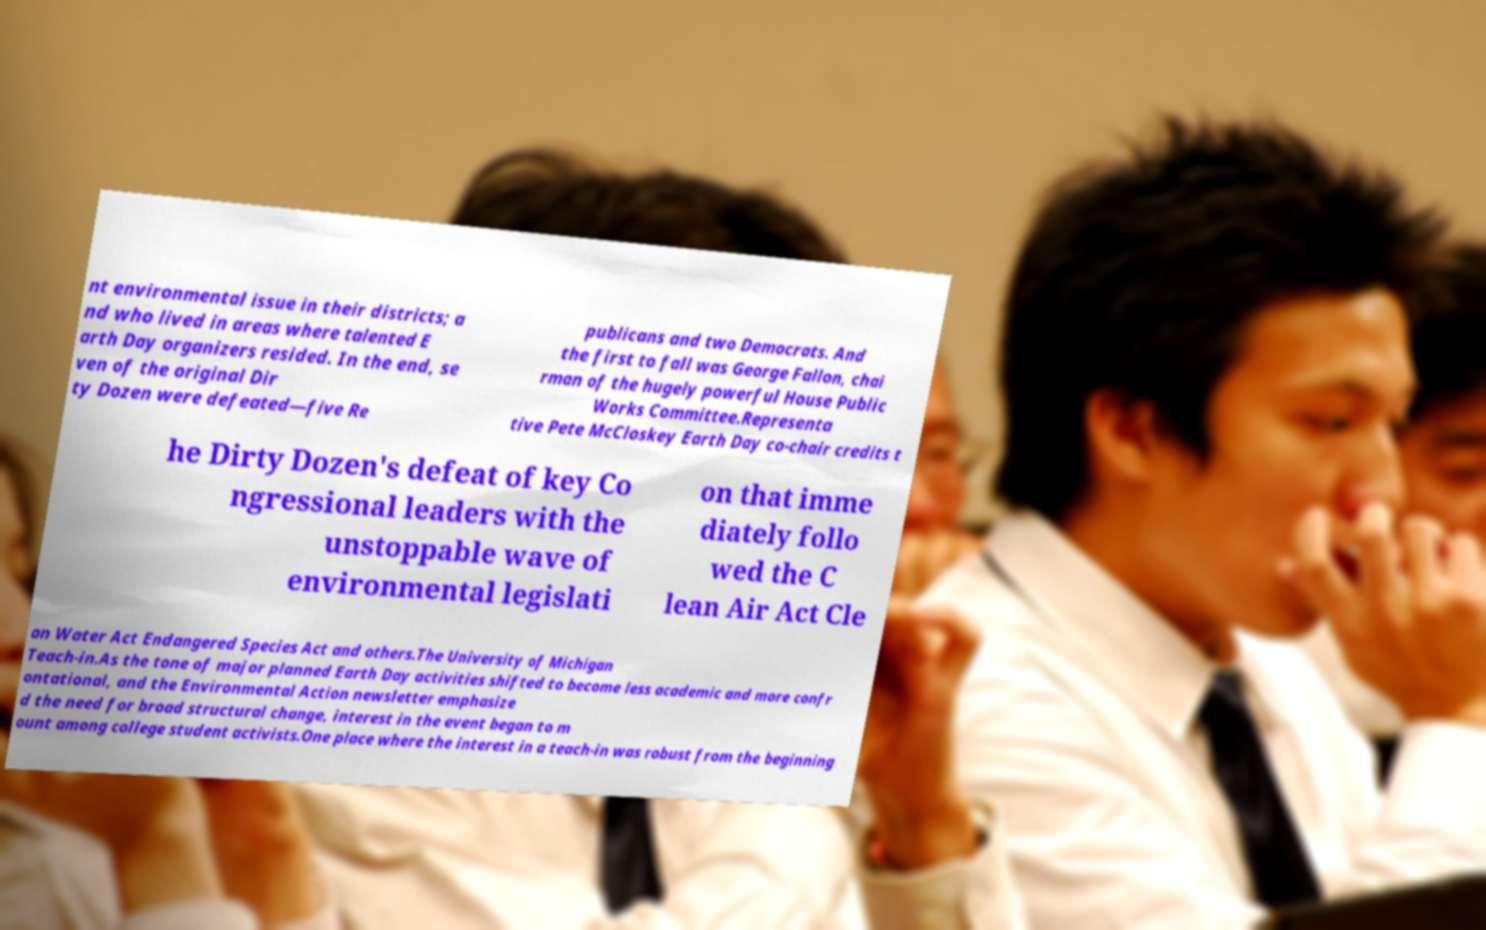For documentation purposes, I need the text within this image transcribed. Could you provide that? nt environmental issue in their districts; a nd who lived in areas where talented E arth Day organizers resided. In the end, se ven of the original Dir ty Dozen were defeated—five Re publicans and two Democrats. And the first to fall was George Fallon, chai rman of the hugely powerful House Public Works Committee.Representa tive Pete McCloskey Earth Day co-chair credits t he Dirty Dozen's defeat of key Co ngressional leaders with the unstoppable wave of environmental legislati on that imme diately follo wed the C lean Air Act Cle an Water Act Endangered Species Act and others.The University of Michigan Teach-in.As the tone of major planned Earth Day activities shifted to become less academic and more confr ontational, and the Environmental Action newsletter emphasize d the need for broad structural change, interest in the event began to m ount among college student activists.One place where the interest in a teach-in was robust from the beginning 